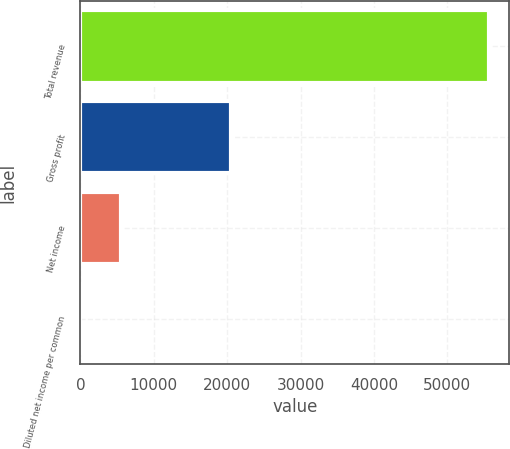Convert chart to OTSL. <chart><loc_0><loc_0><loc_500><loc_500><bar_chart><fcel>Total revenue<fcel>Gross profit<fcel>Net income<fcel>Diluted net income per common<nl><fcel>55648<fcel>20591<fcel>5564.85<fcel>0.06<nl></chart> 